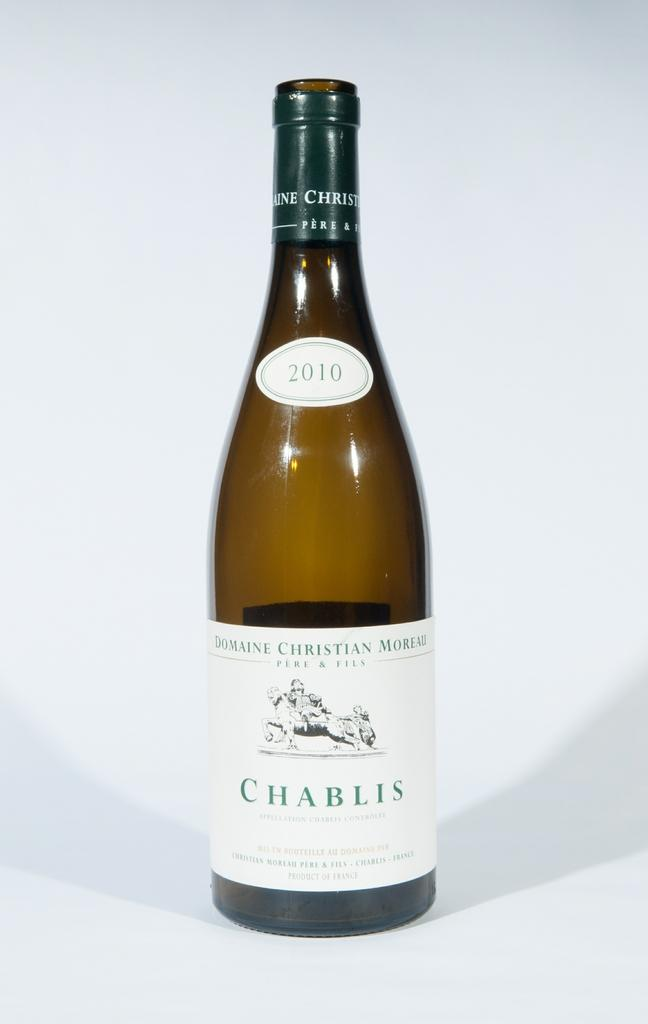<image>
Relay a brief, clear account of the picture shown. An empty bottle of 2010 Chablis from Domain Christian Moreau winery. 